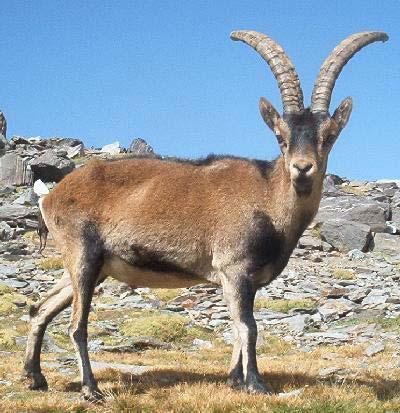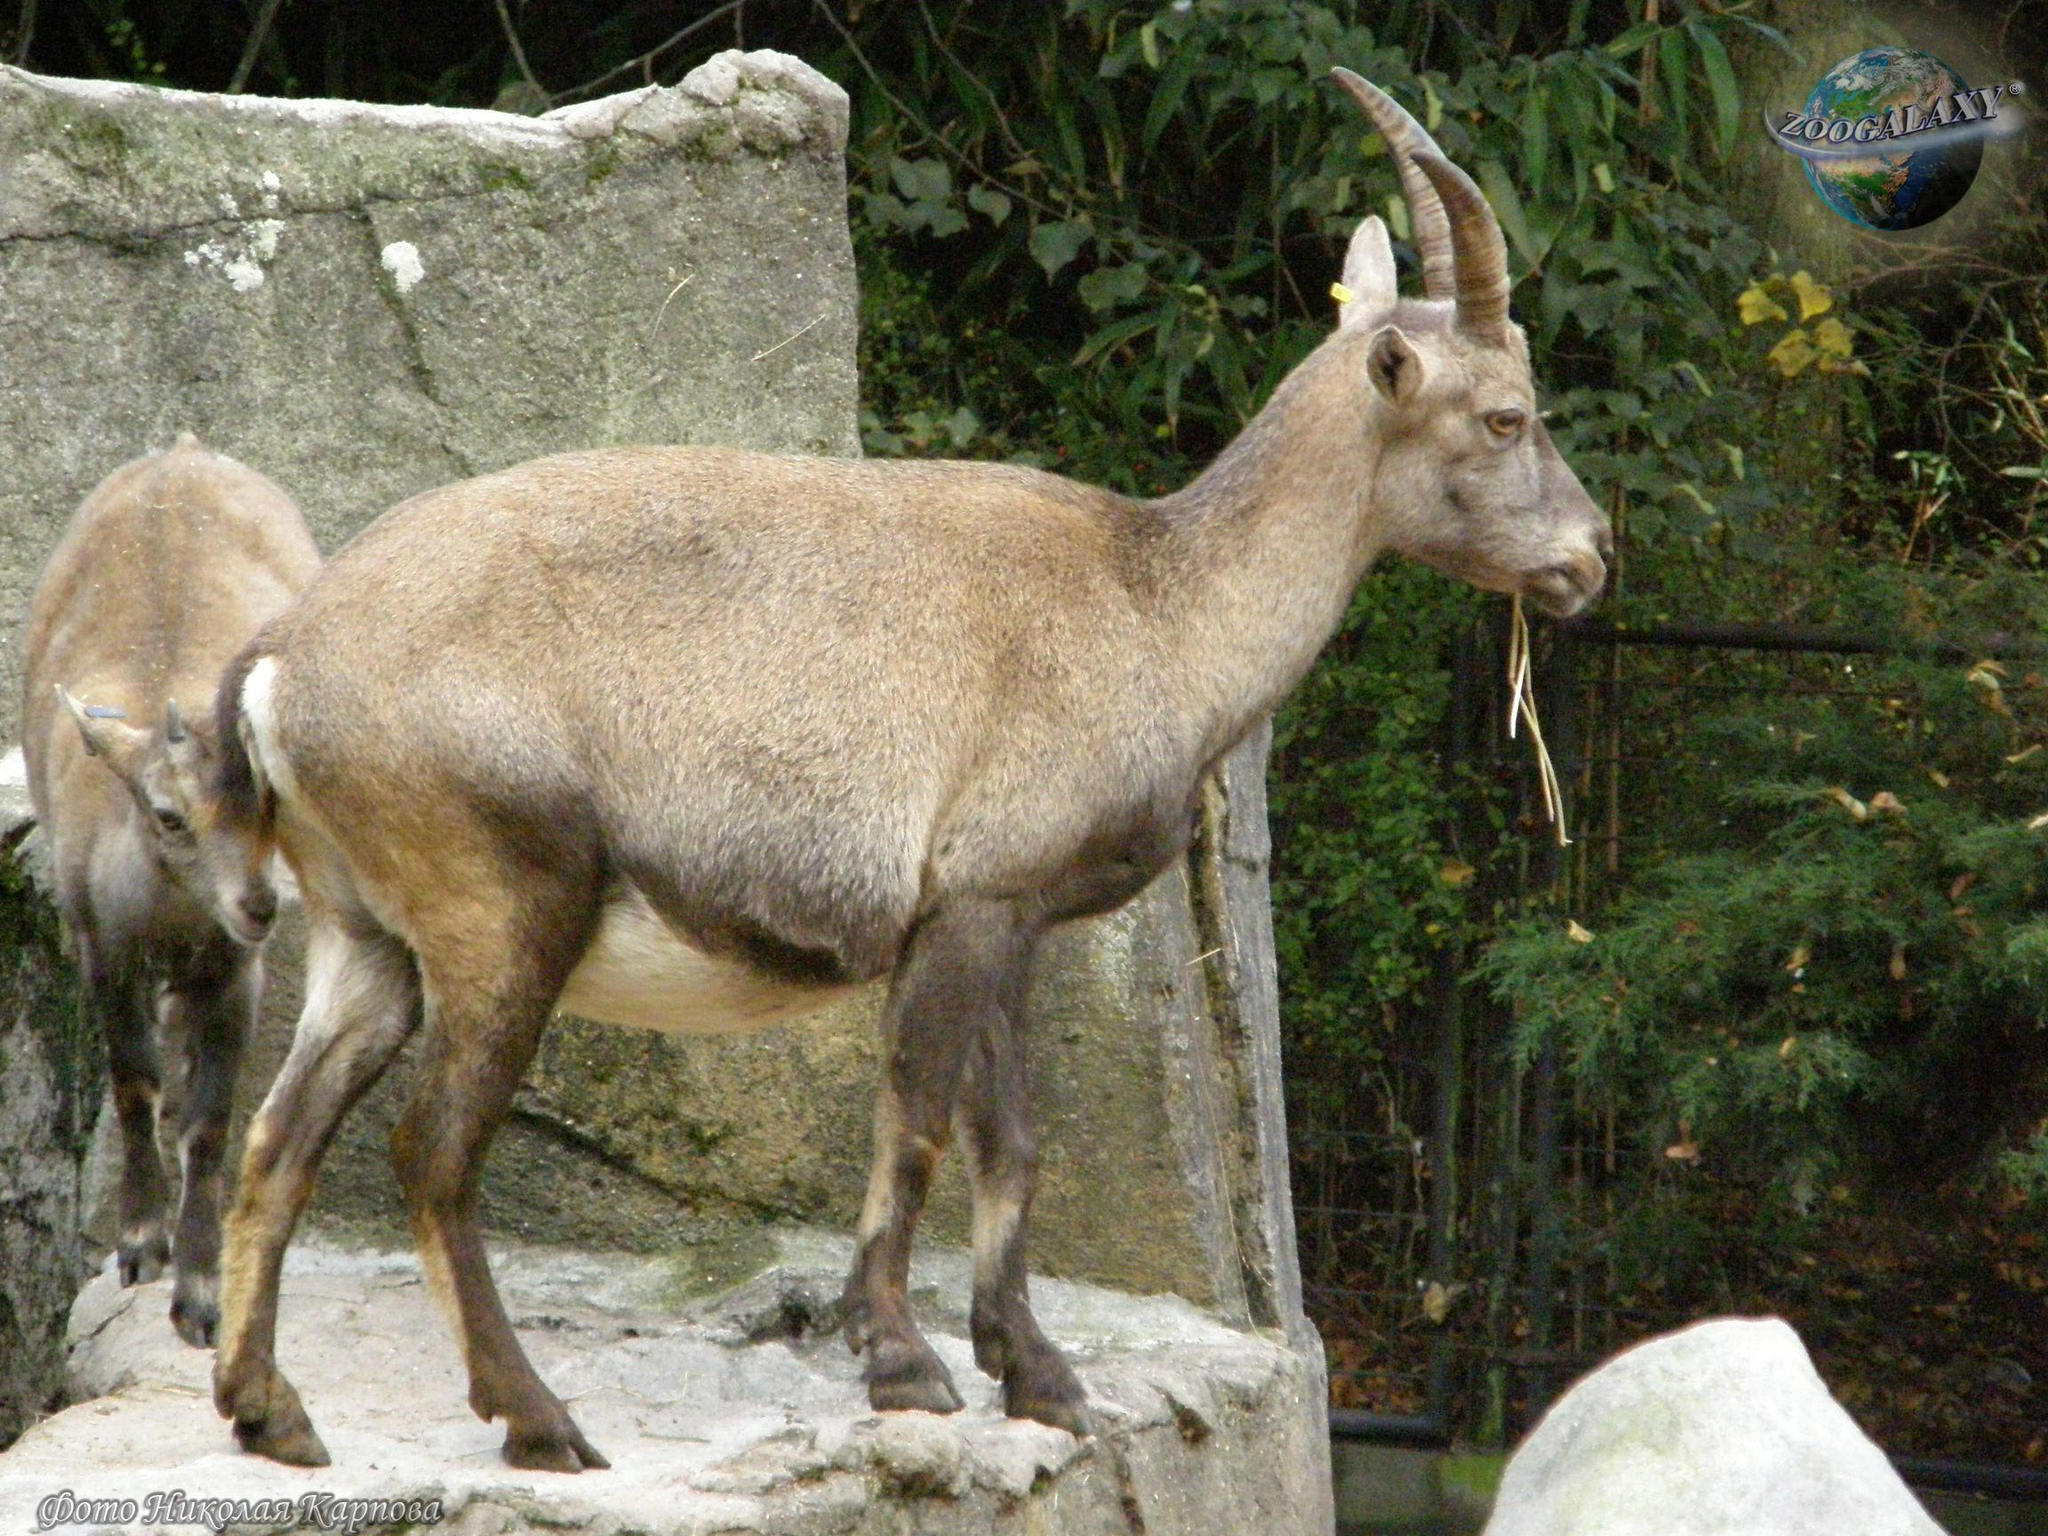The first image is the image on the left, the second image is the image on the right. Evaluate the accuracy of this statement regarding the images: "Left image shows one horned animal standing with its body turned rightward.". Is it true? Answer yes or no. Yes. 